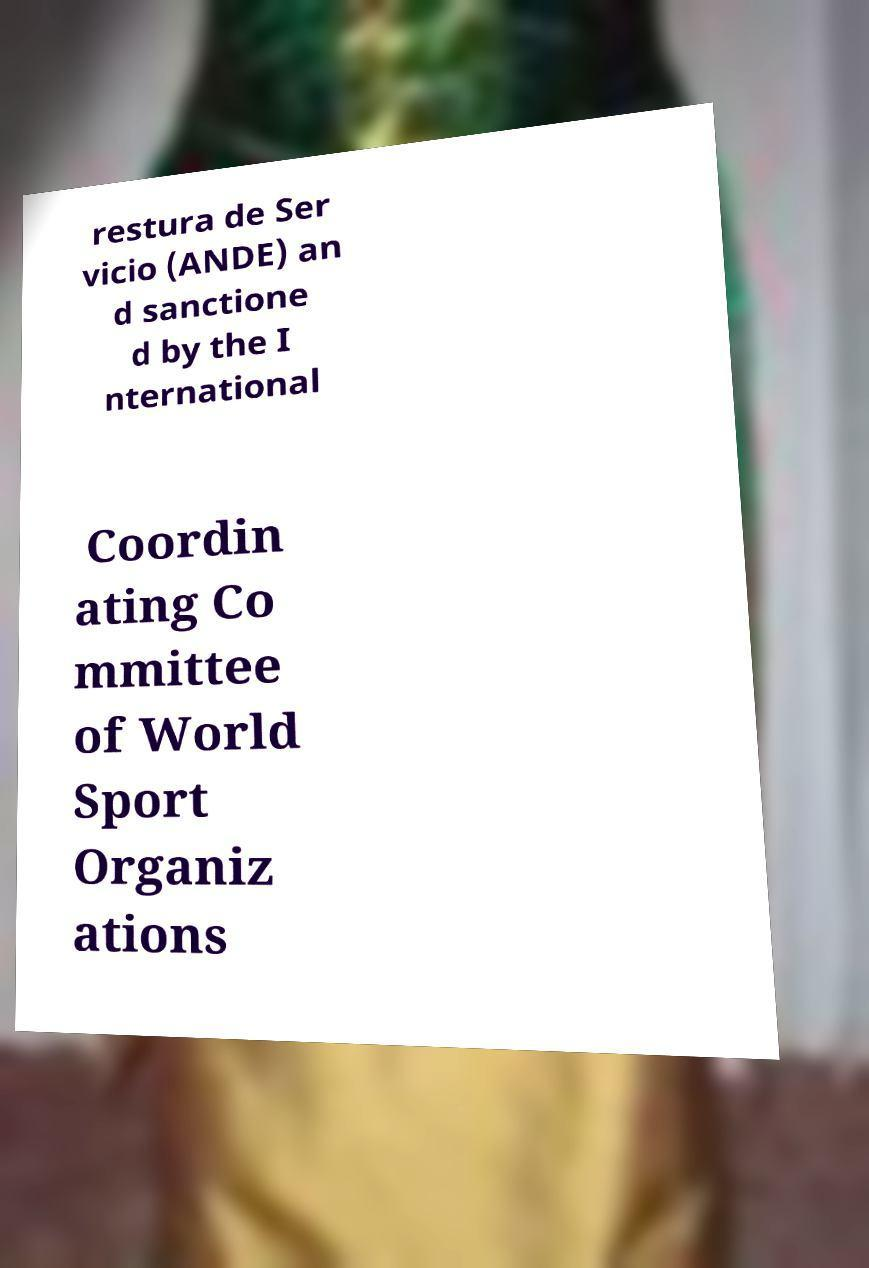Can you accurately transcribe the text from the provided image for me? restura de Ser vicio (ANDE) an d sanctione d by the I nternational Coordin ating Co mmittee of World Sport Organiz ations 